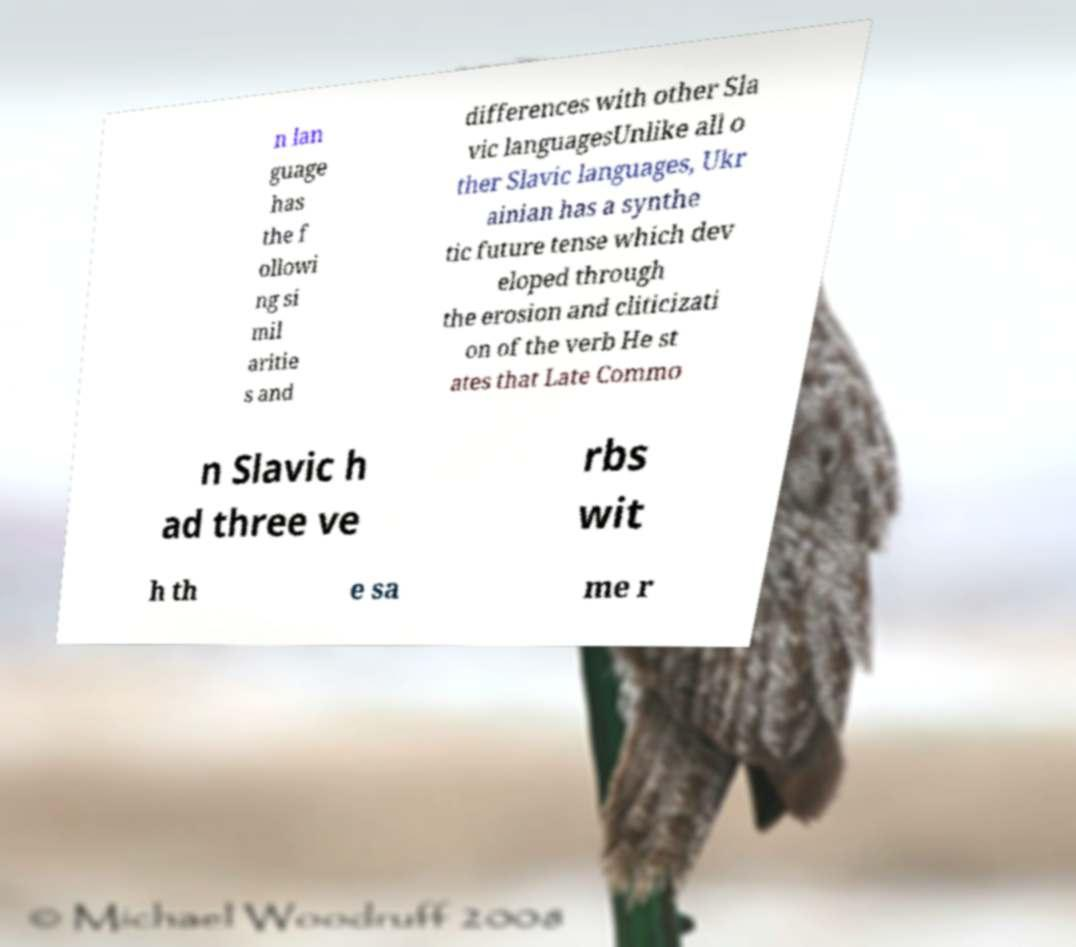Can you read and provide the text displayed in the image?This photo seems to have some interesting text. Can you extract and type it out for me? n lan guage has the f ollowi ng si mil aritie s and differences with other Sla vic languagesUnlike all o ther Slavic languages, Ukr ainian has a synthe tic future tense which dev eloped through the erosion and cliticizati on of the verb He st ates that Late Commo n Slavic h ad three ve rbs wit h th e sa me r 